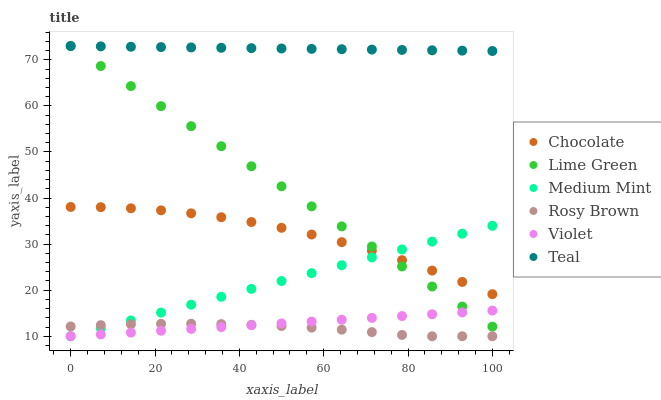Does Rosy Brown have the minimum area under the curve?
Answer yes or no. Yes. Does Teal have the maximum area under the curve?
Answer yes or no. Yes. Does Chocolate have the minimum area under the curve?
Answer yes or no. No. Does Chocolate have the maximum area under the curve?
Answer yes or no. No. Is Violet the smoothest?
Answer yes or no. Yes. Is Chocolate the roughest?
Answer yes or no. Yes. Is Rosy Brown the smoothest?
Answer yes or no. No. Is Rosy Brown the roughest?
Answer yes or no. No. Does Medium Mint have the lowest value?
Answer yes or no. Yes. Does Chocolate have the lowest value?
Answer yes or no. No. Does Lime Green have the highest value?
Answer yes or no. Yes. Does Chocolate have the highest value?
Answer yes or no. No. Is Medium Mint less than Teal?
Answer yes or no. Yes. Is Chocolate greater than Rosy Brown?
Answer yes or no. Yes. Does Lime Green intersect Medium Mint?
Answer yes or no. Yes. Is Lime Green less than Medium Mint?
Answer yes or no. No. Is Lime Green greater than Medium Mint?
Answer yes or no. No. Does Medium Mint intersect Teal?
Answer yes or no. No. 